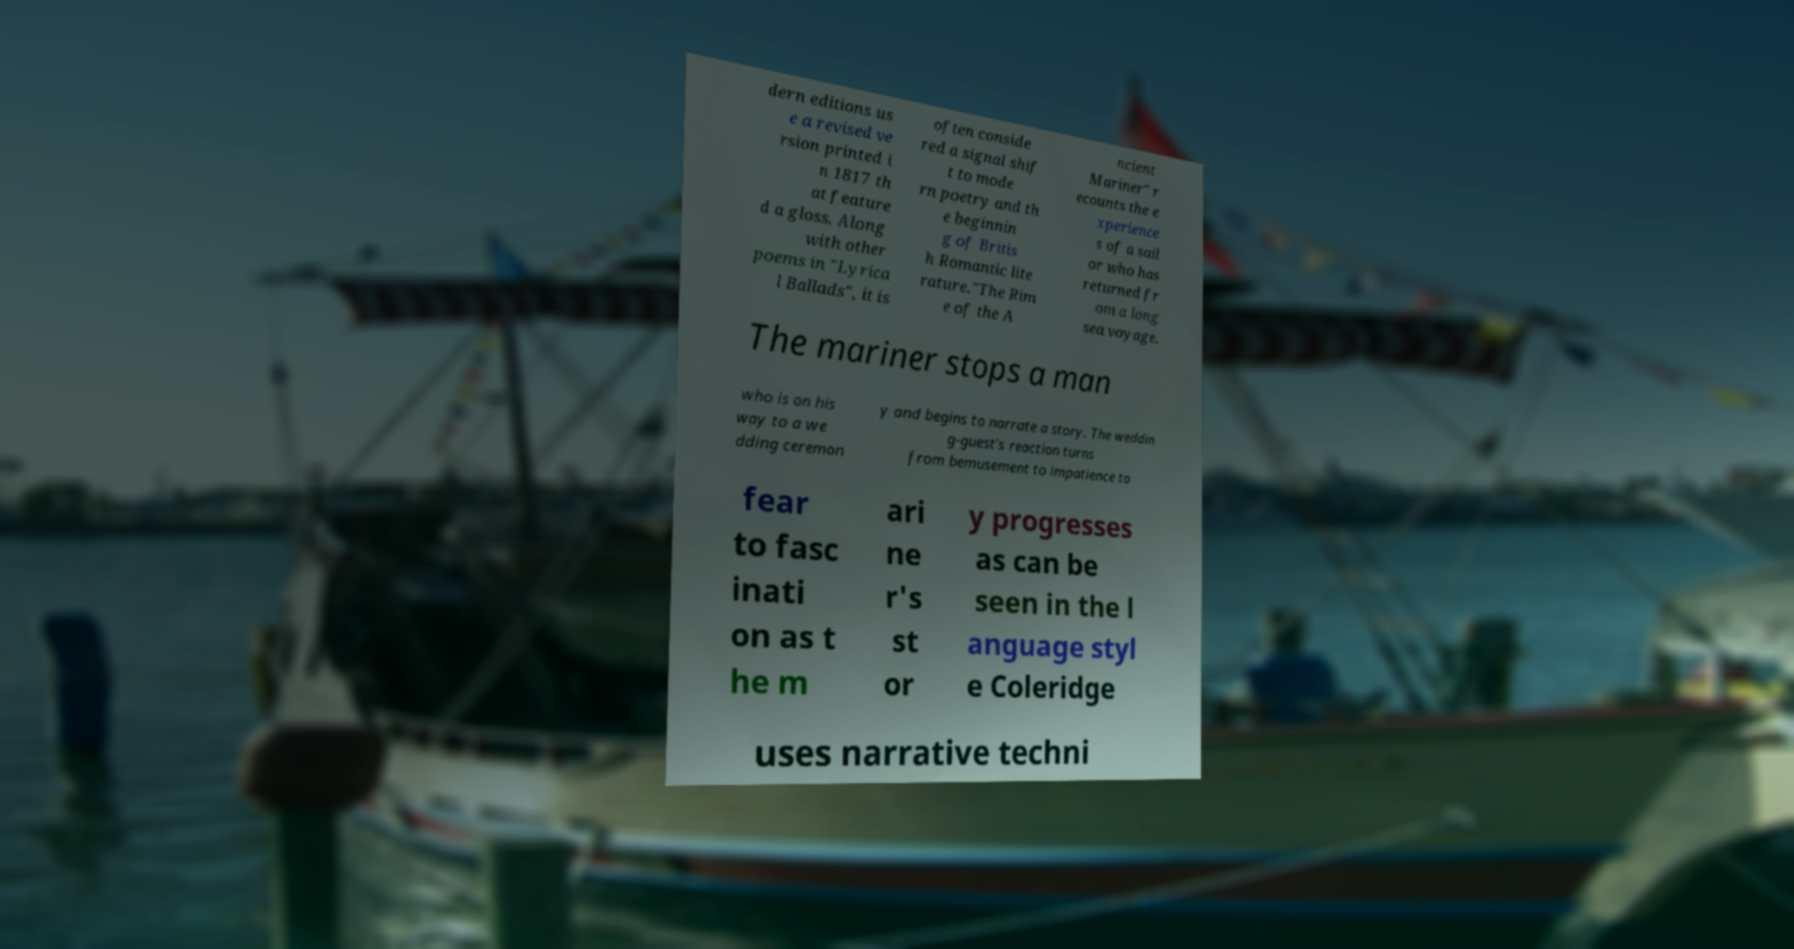What messages or text are displayed in this image? I need them in a readable, typed format. dern editions us e a revised ve rsion printed i n 1817 th at feature d a gloss. Along with other poems in "Lyrica l Ballads", it is often conside red a signal shif t to mode rn poetry and th e beginnin g of Britis h Romantic lite rature."The Rim e of the A ncient Mariner" r ecounts the e xperience s of a sail or who has returned fr om a long sea voyage. The mariner stops a man who is on his way to a we dding ceremon y and begins to narrate a story. The weddin g-guest's reaction turns from bemusement to impatience to fear to fasc inati on as t he m ari ne r's st or y progresses as can be seen in the l anguage styl e Coleridge uses narrative techni 